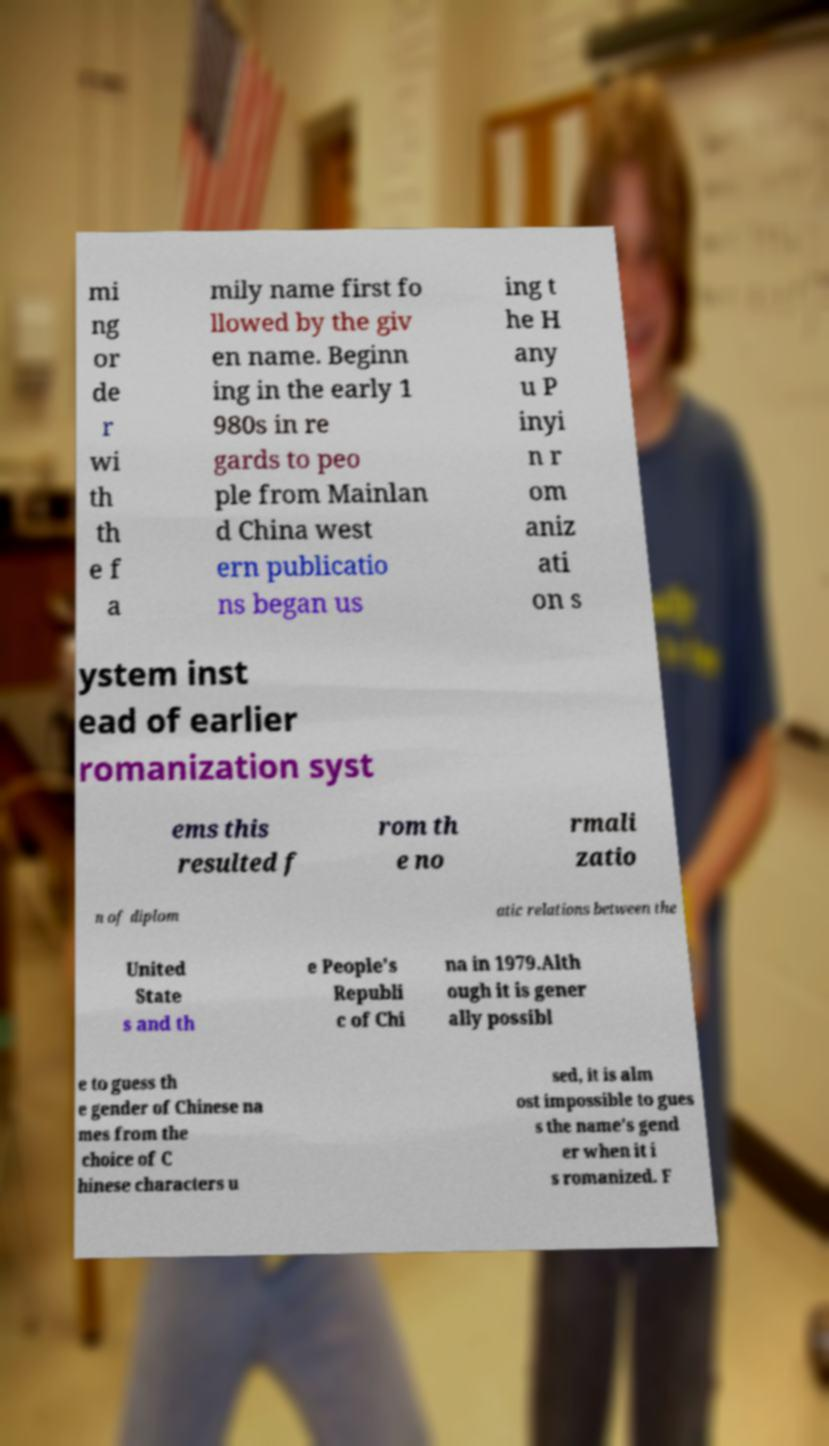Please identify and transcribe the text found in this image. mi ng or de r wi th th e f a mily name first fo llowed by the giv en name. Beginn ing in the early 1 980s in re gards to peo ple from Mainlan d China west ern publicatio ns began us ing t he H any u P inyi n r om aniz ati on s ystem inst ead of earlier romanization syst ems this resulted f rom th e no rmali zatio n of diplom atic relations between the United State s and th e People's Republi c of Chi na in 1979.Alth ough it is gener ally possibl e to guess th e gender of Chinese na mes from the choice of C hinese characters u sed, it is alm ost impossible to gues s the name's gend er when it i s romanized. F 